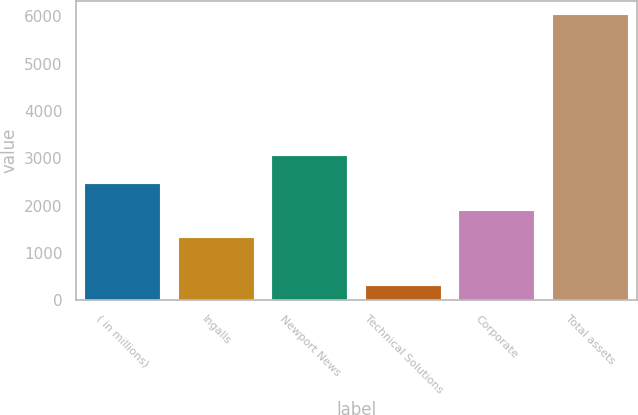Convert chart. <chart><loc_0><loc_0><loc_500><loc_500><bar_chart><fcel>( in millions)<fcel>Ingalls<fcel>Newport News<fcel>Technical Solutions<fcel>Corporate<fcel>Total assets<nl><fcel>2468.2<fcel>1324<fcel>3061<fcel>303<fcel>1896.1<fcel>6024<nl></chart> 